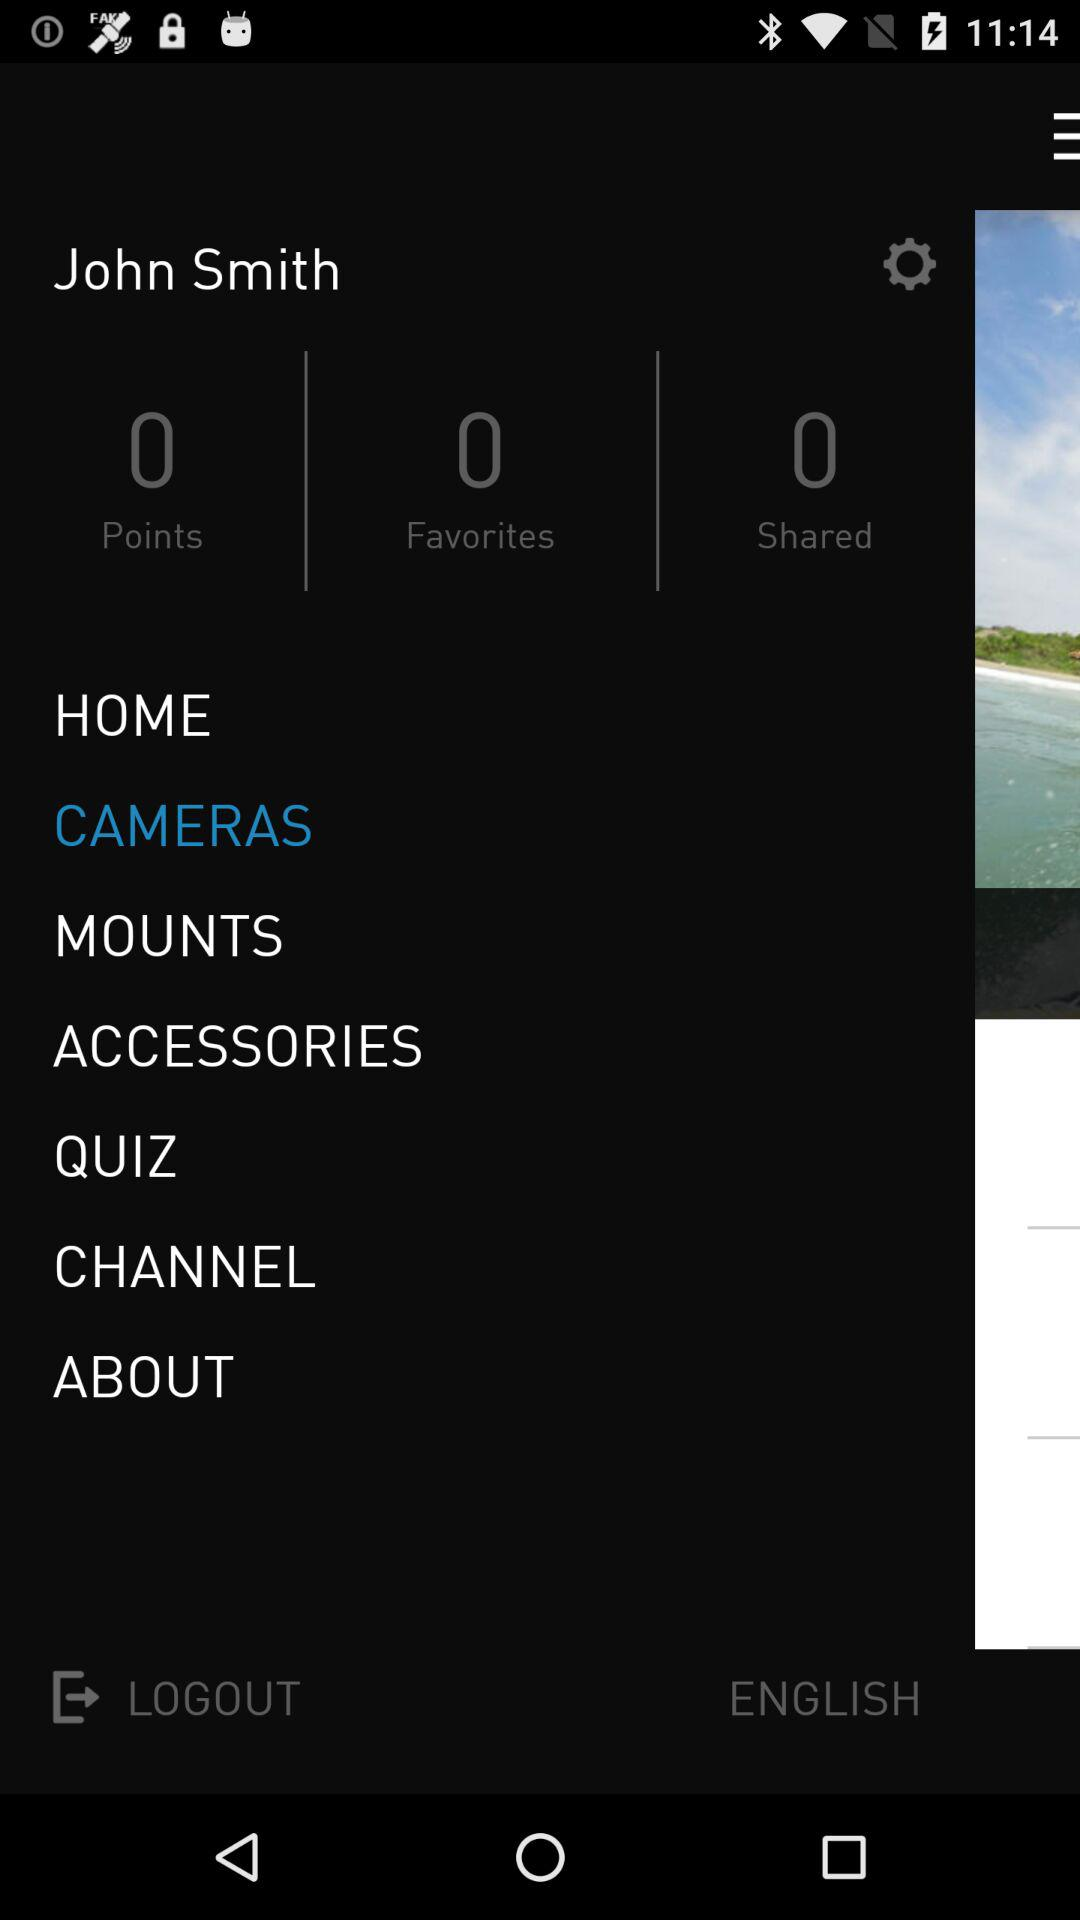Which option is selected? The selected option is "CAMERAS". 